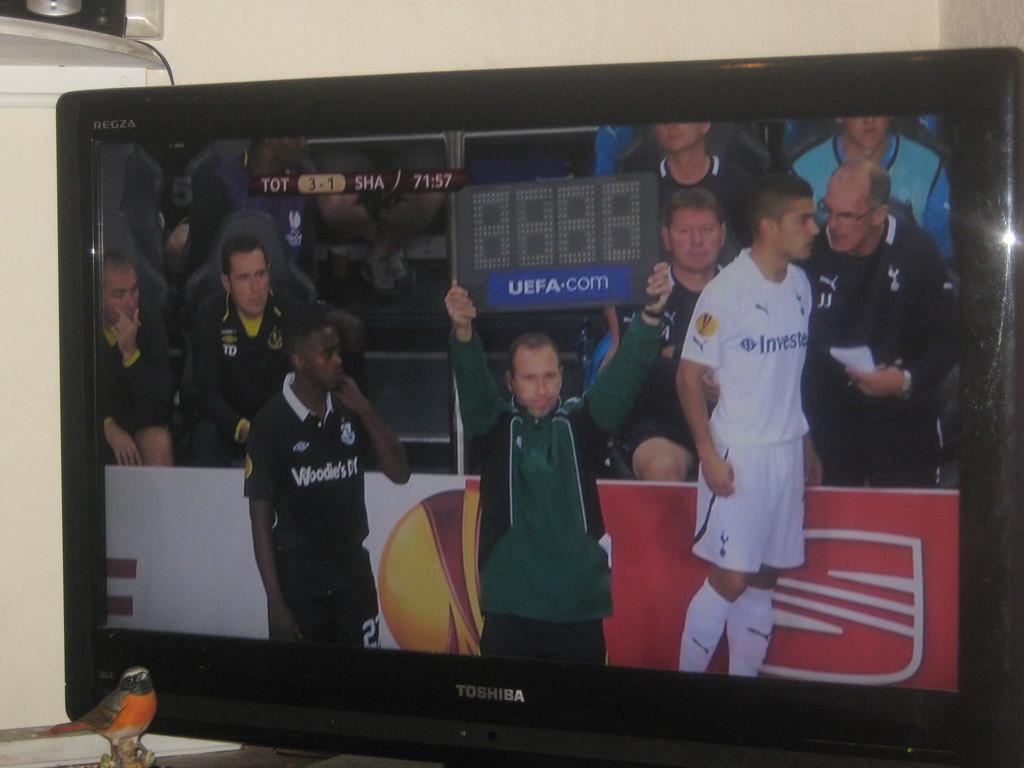What teams are playing?
Your answer should be very brief. Tot and sha. What is the score?
Keep it short and to the point. 3-1. 